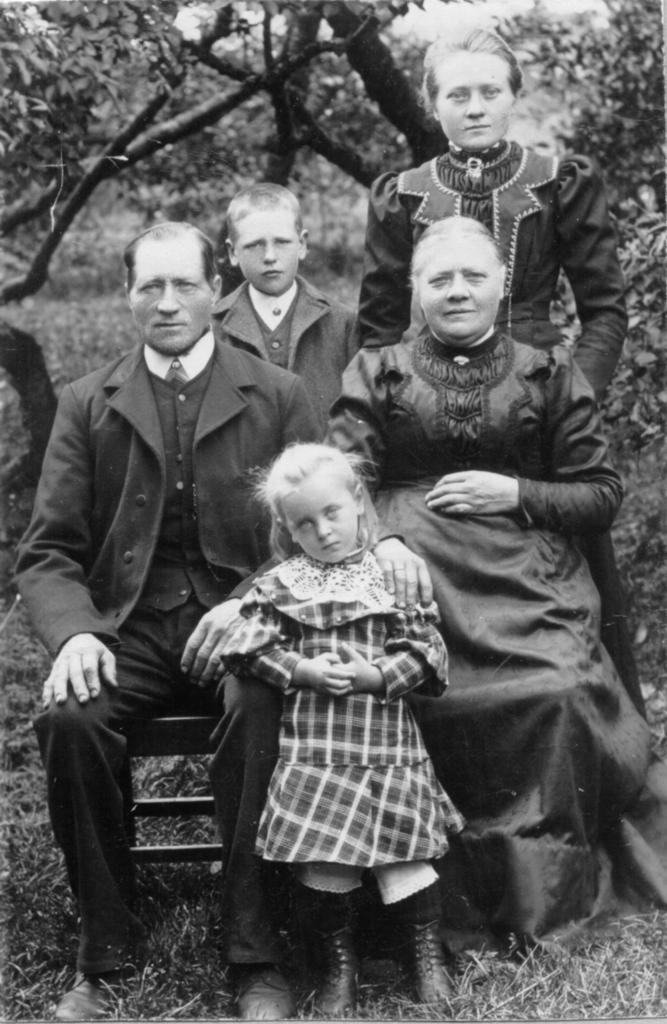How many people are present in the image? There are four people in the image: a man, two women, and a boy. Can you describe the gender of the individuals in the image? There is a man, two women, and a boy in the image. What can be seen in the background of the image? Trees are visible in the background of the image. How many pizzas are being served to the dad in the image? There is no dad or pizzas present in the image. What sense is being stimulated by the presence of the trees in the background? The provided facts do not mention any sensory experiences related to the trees in the background. 